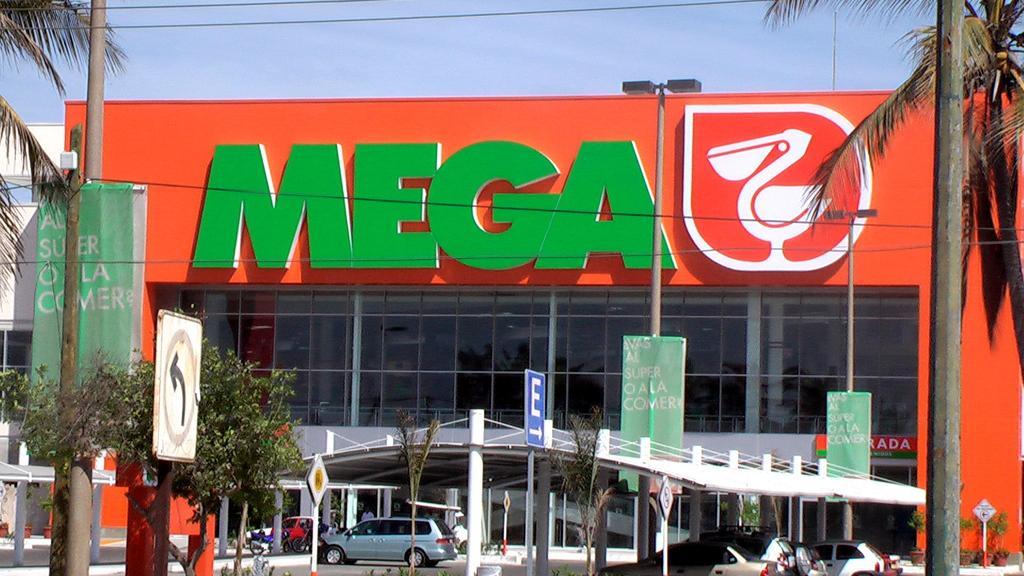Could you give a brief overview of what you see in this image? In this image there are trees, sign, boards, in the background there is shed, under the shed there are cars, and there is a mall and the sky. 